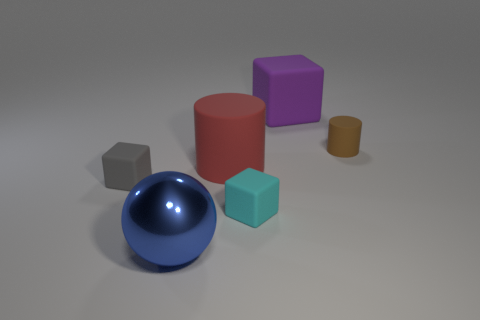How many gray rubber objects have the same size as the purple object?
Provide a short and direct response. 0. What is the material of the other small object that is the same shape as the cyan matte thing?
Ensure brevity in your answer.  Rubber. What is the shape of the tiny thing that is on the right side of the blue ball and behind the cyan block?
Ensure brevity in your answer.  Cylinder. There is a big rubber object that is on the left side of the tiny cyan rubber object; what is its shape?
Keep it short and to the point. Cylinder. How many rubber cubes are both right of the tiny gray matte block and in front of the purple object?
Your response must be concise. 1. Is the size of the blue metal sphere the same as the cube that is behind the tiny gray cube?
Provide a succinct answer. Yes. There is a block behind the cylinder to the left of the cylinder that is right of the tiny cyan rubber cube; how big is it?
Provide a short and direct response. Large. There is a thing left of the large blue metallic object; what size is it?
Your response must be concise. Small. The tiny gray thing that is made of the same material as the big purple thing is what shape?
Ensure brevity in your answer.  Cube. Does the tiny cube to the left of the red matte cylinder have the same material as the purple thing?
Provide a short and direct response. Yes. 